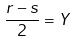<formula> <loc_0><loc_0><loc_500><loc_500>\frac { r - s } { 2 } = Y</formula> 